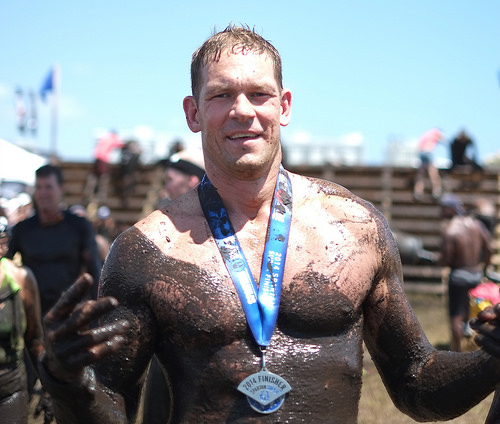<image>
Is there a medal on the man? Yes. Looking at the image, I can see the medal is positioned on top of the man, with the man providing support. Is there a medal to the left of the mud? No. The medal is not to the left of the mud. From this viewpoint, they have a different horizontal relationship. 